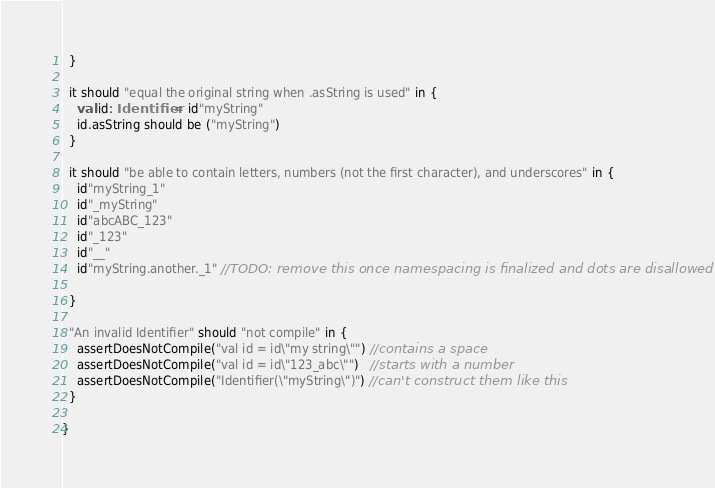Convert code to text. <code><loc_0><loc_0><loc_500><loc_500><_Scala_>  }

  it should "equal the original string when .asString is used" in {
    val id: Identifier = id"myString"
    id.asString should be ("myString")
  }

  it should "be able to contain letters, numbers (not the first character), and underscores" in {
    id"myString_1"
    id"_myString"
    id"abcABC_123"
    id"_123"
    id"__"
    id"myString.another._1" //TODO: remove this once namespacing is finalized and dots are disallowed

  }

  "An invalid Identifier" should "not compile" in {
    assertDoesNotCompile("val id = id\"my string\"") //contains a space
    assertDoesNotCompile("val id = id\"123_abc\"")   //starts with a number
    assertDoesNotCompile("Identifier(\"myString\")") //can't construct them like this
  }

}
</code> 